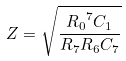<formula> <loc_0><loc_0><loc_500><loc_500>Z = \sqrt { \frac { { R _ { 0 } } ^ { 7 } C _ { 1 } } { R _ { 7 } R _ { 6 } C _ { 7 } } }</formula> 